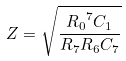<formula> <loc_0><loc_0><loc_500><loc_500>Z = \sqrt { \frac { { R _ { 0 } } ^ { 7 } C _ { 1 } } { R _ { 7 } R _ { 6 } C _ { 7 } } }</formula> 